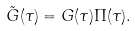Convert formula to latex. <formula><loc_0><loc_0><loc_500><loc_500>\tilde { G } ( \tau ) = G ( \tau ) \Pi ( \tau ) .</formula> 